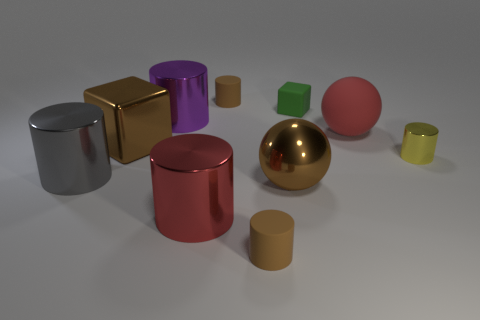What materials can be seen in the objects in the image? The objects in the image appear to be made from a variety of materials including metallic surfaces in gold, silver, and red, as well as what looks like a matte finish on the green and brown objects. 